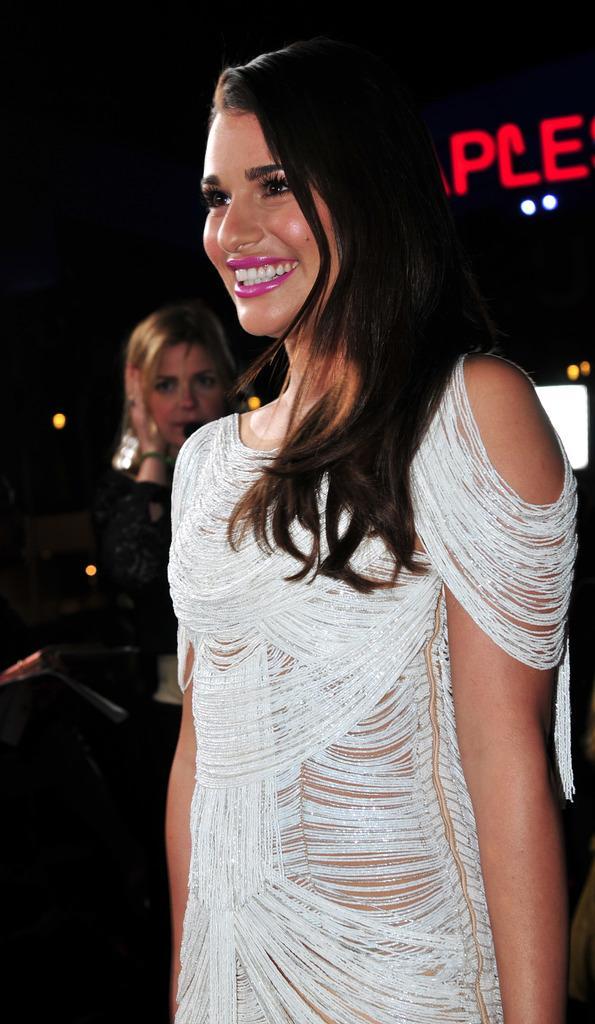Could you give a brief overview of what you see in this image? In the image there is a woman, she is wearing white dress and she is smiling behind her there is another woman and in the background there is some name. 